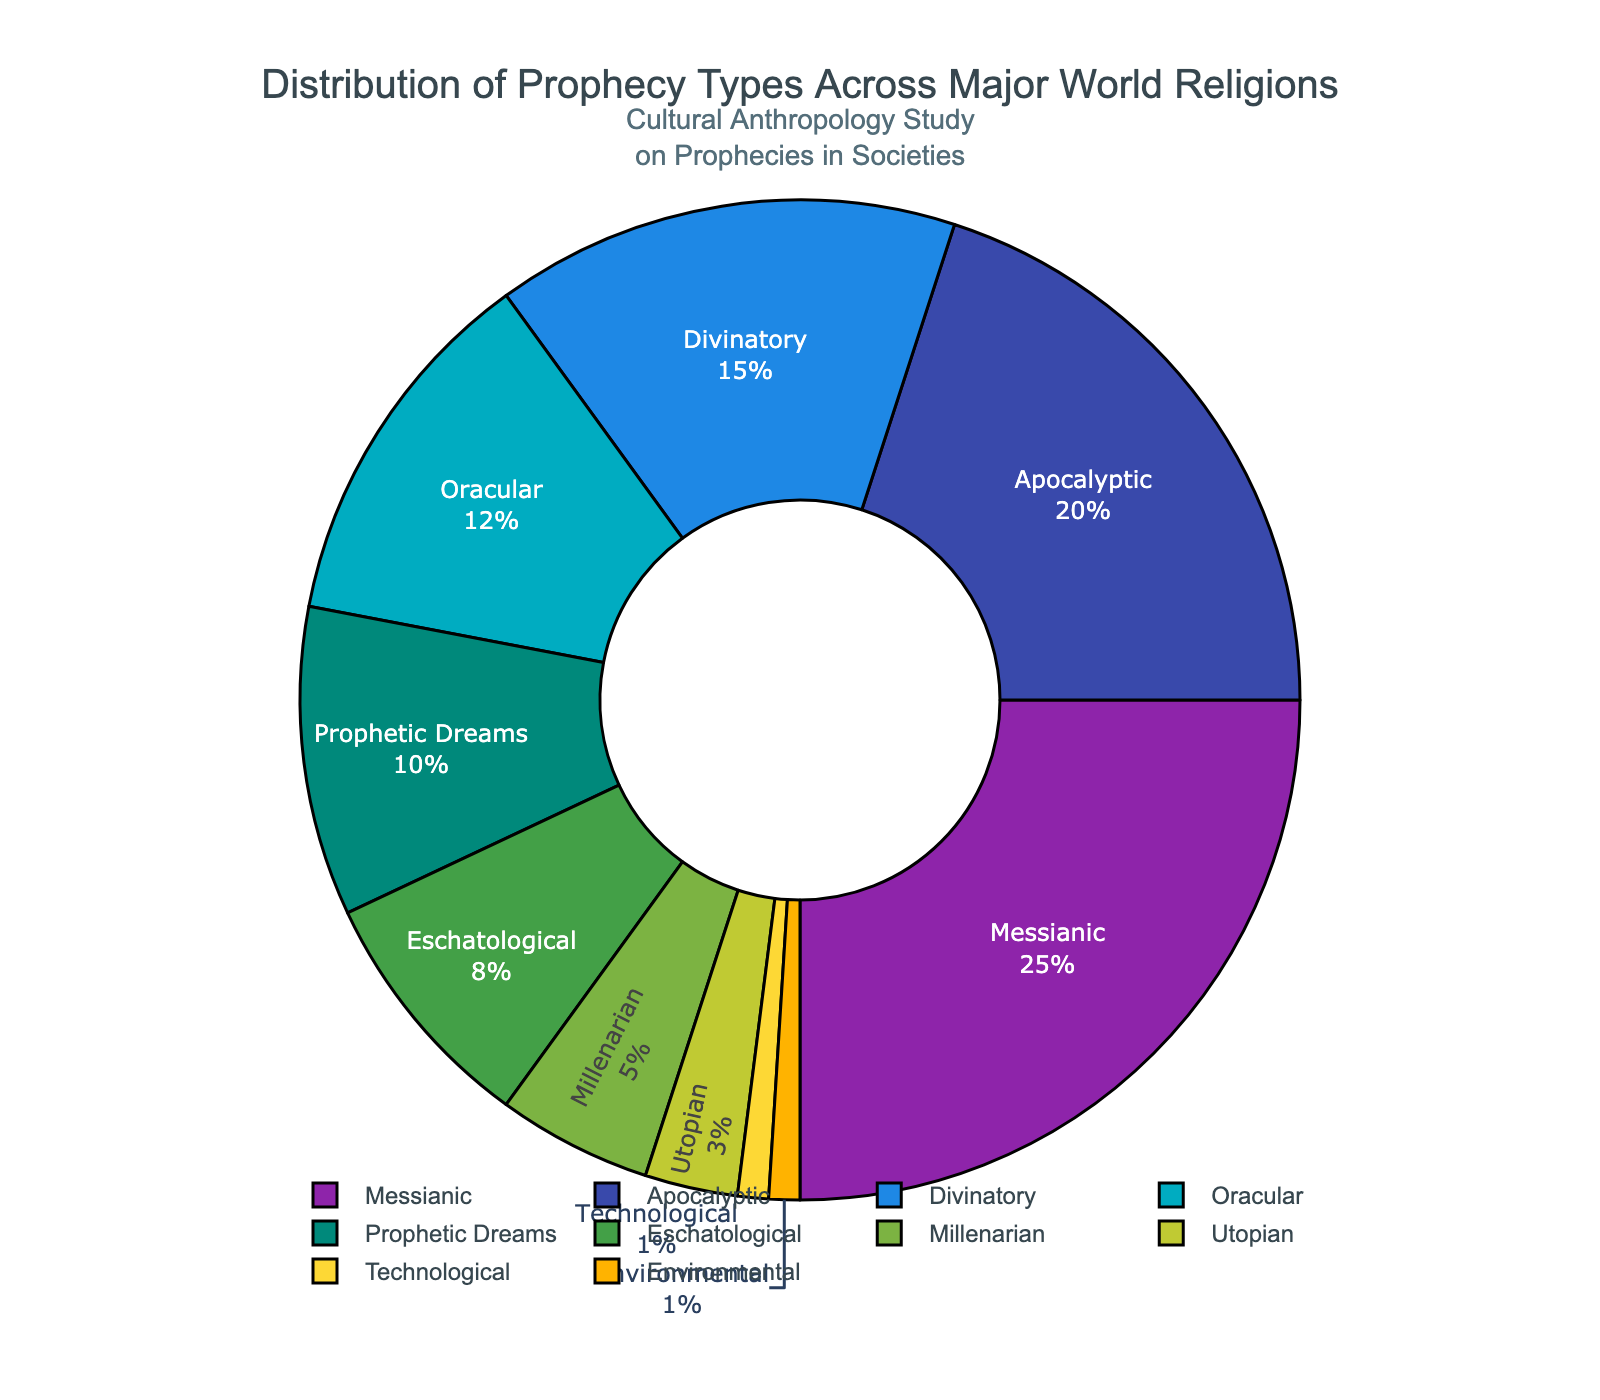What percentage of prophecies are classified as Apocalyptic? The pie chart shows the distribution of different types of prophecies with their respective percentages. Locate the section labeled "Apocalyptic" and read its value.
Answer: 20% Which type of prophecy has the smallest percentage? The smallest percentage on the pie chart can be found by locating the section with the smallest slice or label. The segments labeled "Technological" and "Environmental" each have the smallest percentages.
Answer: Technological and Environmental How much larger is the percentage of Messianic prophecies compared to Eschatological prophecies? The pie chart shows that Messianic prophecies are 25% and Eschatological prophecies are 8%. Subtract the Eschatological percentage from the Messianic percentage: 25% - 8% = 17%.
Answer: 17% Which type of prophecy occupies a larger portion of the chart: Divinatory or Oracular? Locate the sections labeled "Divinatory" and "Oracular" on the pie chart. Divinatory prophecies are 15% while Oracular prophecies are 12%.
Answer: Divinatory What is the total percentage of prophecies classified as Utopian and Millenarian? Add the percentages for Utopian (3%) and Millenarian (5%) prophecies: 3% + 5% = 8%.
Answer: 8% If the pie chart were initially rotated to place Messianic prophecies at the top, which type of prophecy would be next in a clockwise direction? The pie chart is initially rotated 90 degrees. The section next to Messianic in a clockwise direction is Apocalyptic as these two sections are adjacent.
Answer: Apocalyptic Which two types of prophecies together make up exactly 30% of the total? From the pie chart, Messianic (25%) and Environmental (1%) add up to 26%, Messianic (25%) and Technological (1%) add up to 26%, and Apocalyptic (20%) and Prophetic Dreams (10%) add up to 30%.
Answer: Apocalyptic and Prophetic Dreams Among Oracular, Prophetic Dreams, and Eschatological prophecies, which has the highest percentage? Compare the percentages of the three types: Oracular (12%), Prophetic Dreams (10%), and Eschatological (8%). Oracular has the highest percentage.
Answer: Oracular What is the combined percentage of Apocalyptic, Divinatory, and Utopian prophecies? Sum the percentages for Apocalyptic (20%), Divinatory (15%), and Utopian (3%): 20% + 15% + 3% = 38%.
Answer: 38% How many types of prophecies are there where the percentage is greater than or equal to 10%? From the pie chart, identify the sections with percentages greater than or equal to 10%. These are Messianic (25%), Apocalyptic (20%), Divinatory (15%), Oracular (12%), and Prophetic Dreams (10%). Count these categories: 5 types.
Answer: 5 